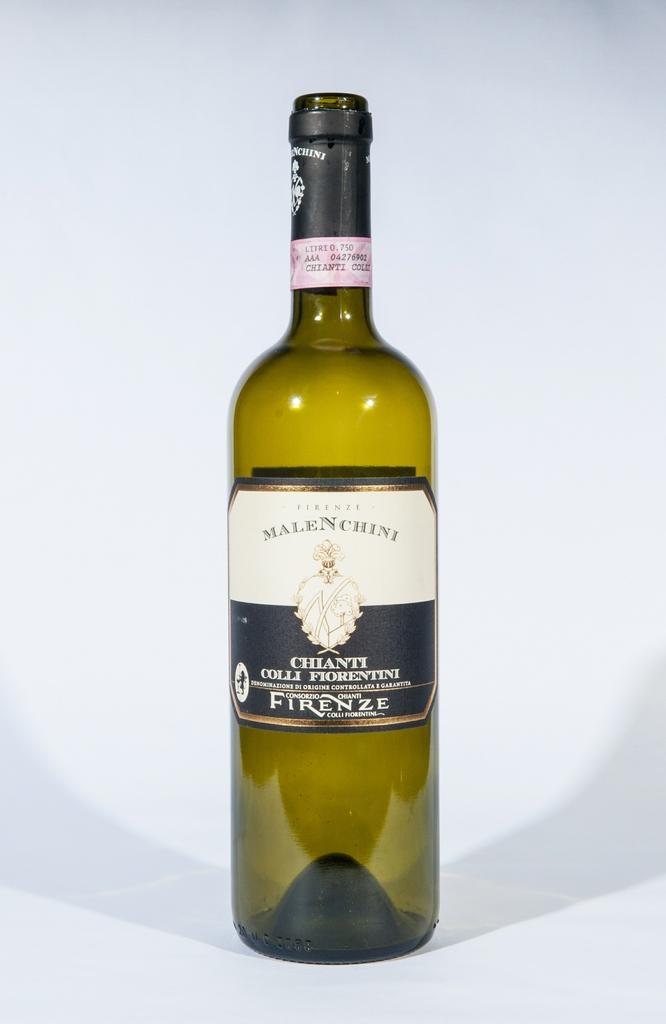Is chanti american?
Your response must be concise. No. Is this a firenze bottle?
Your response must be concise. Yes. 